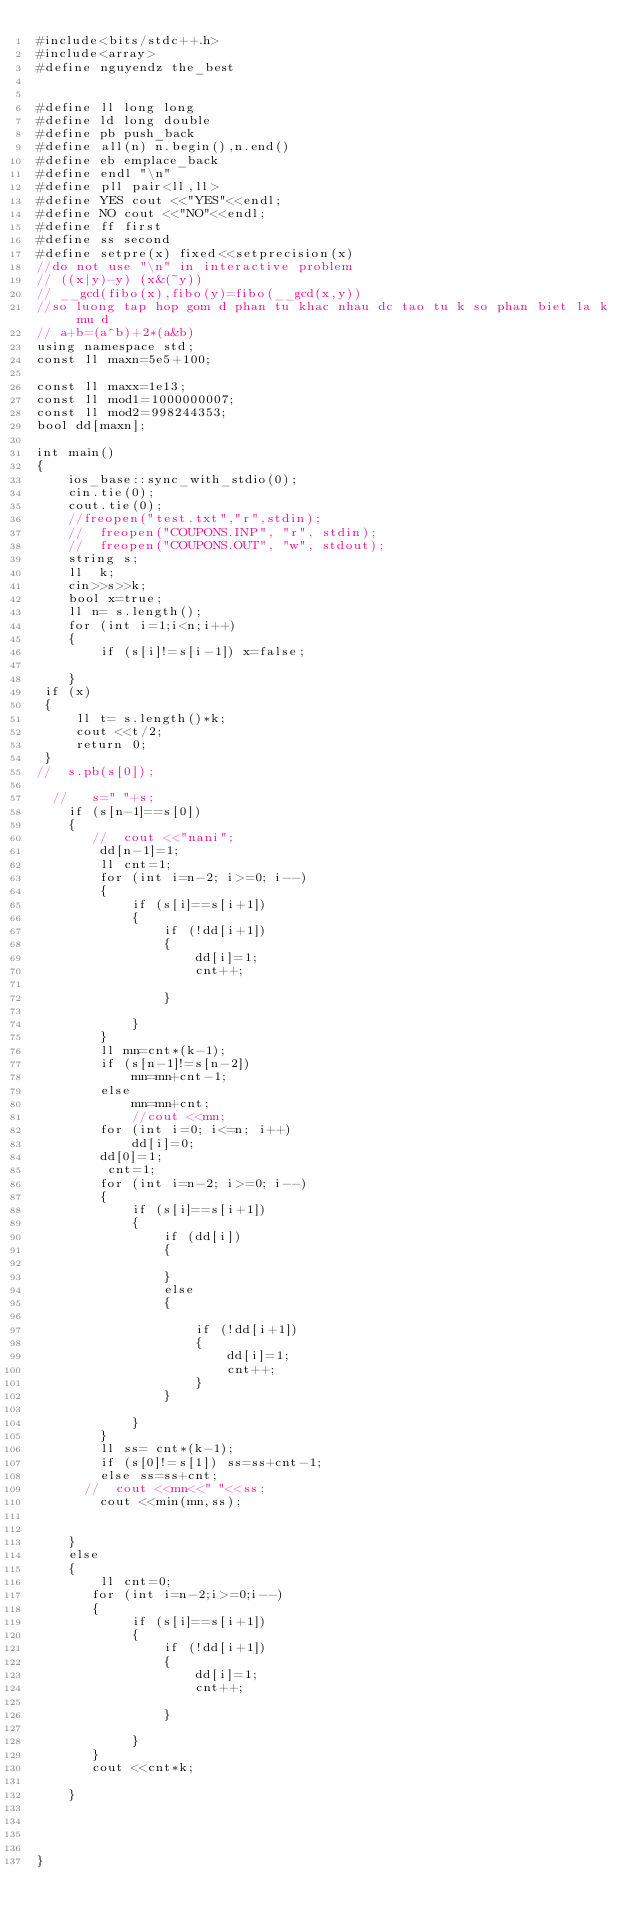Convert code to text. <code><loc_0><loc_0><loc_500><loc_500><_C++_>#include<bits/stdc++.h>
#include<array>
#define nguyendz the_best


#define ll long long
#define ld long double
#define pb push_back
#define all(n) n.begin(),n.end()
#define eb emplace_back
#define endl "\n"
#define pll pair<ll,ll>
#define YES cout <<"YES"<<endl;
#define NO cout <<"NO"<<endl;
#define ff first
#define ss second
#define setpre(x) fixed<<setprecision(x)
//do not use "\n" in interactive problem
// ((x|y)-y) (x&(~y))
// __gcd(fibo(x),fibo(y)=fibo(__gcd(x,y))
//so luong tap hop gom d phan tu khac nhau dc tao tu k so phan biet la k mu d
// a+b=(a^b)+2*(a&b)
using namespace std;
const ll maxn=5e5+100;

const ll maxx=1e13;
const ll mod1=1000000007;
const ll mod2=998244353;
bool dd[maxn];

int main()
{
    ios_base::sync_with_stdio(0);
    cin.tie(0);
    cout.tie(0);
    //freopen("test.txt","r",stdin);
    //  freopen("COUPONS.INP", "r", stdin);
    //  freopen("COUPONS.OUT", "w", stdout);
    string s;
    ll  k;
    cin>>s>>k;
    bool x=true;
    ll n= s.length();
    for (int i=1;i<n;i++)
    {
        if (s[i]!=s[i-1]) x=false;

    }
 if (x)
 {
     ll t= s.length()*k;
     cout <<t/2;
     return 0;
 }
//  s.pb(s[0]);

  //   s=" "+s;
    if (s[n-1]==s[0])
    {
       //  cout <<"nani";
        dd[n-1]=1;
        ll cnt=1;
        for (int i=n-2; i>=0; i--)
        {
            if (s[i]==s[i+1])
            {
                if (!dd[i+1])
                {
                    dd[i]=1;
                    cnt++;

                }

            }
        }
        ll mn=cnt*(k-1);
        if (s[n-1]!=s[n-2])
            mn=mn+cnt-1;
        else
            mn=mn+cnt;
            //cout <<mn;
        for (int i=0; i<=n; i++)
            dd[i]=0;
        dd[0]=1;
         cnt=1;
        for (int i=n-2; i>=0; i--)
        {
            if (s[i]==s[i+1])
            {
                if (dd[i])
                {

                }
                else
                {

                    if (!dd[i+1])
                    {
                        dd[i]=1;
                        cnt++;
                    }
                }

            }
        }
        ll ss= cnt*(k-1);
        if (s[0]!=s[1]) ss=ss+cnt-1;
        else ss=ss+cnt;
      //  cout <<mn<<" "<<ss;
        cout <<min(mn,ss);


    }
    else
    {
        ll cnt=0;
       for (int i=n-2;i>=0;i--)
       {
            if (s[i]==s[i+1])
            {
                if (!dd[i+1])
                {
                    dd[i]=1;
                    cnt++;

                }

            }
       }
       cout <<cnt*k;

    }




}

























</code> 